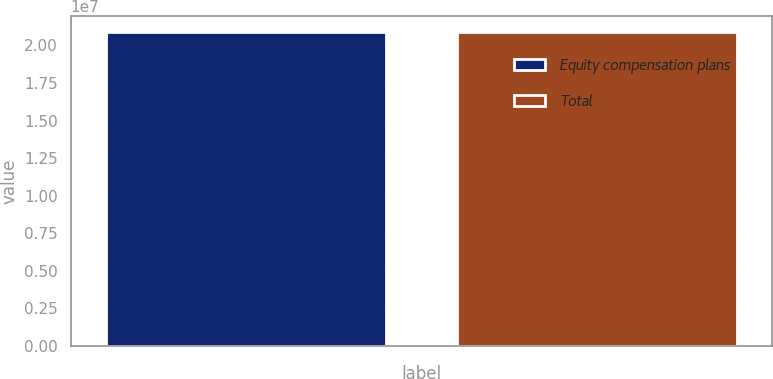<chart> <loc_0><loc_0><loc_500><loc_500><bar_chart><fcel>Equity compensation plans<fcel>Total<nl><fcel>2.08779e+07<fcel>2.08779e+07<nl></chart> 